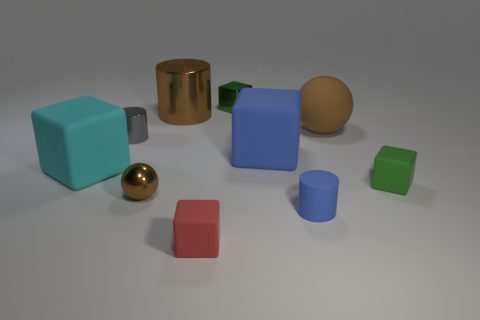Subtract all small red matte blocks. How many blocks are left? 4 Subtract all red blocks. How many blocks are left? 4 Subtract all brown cubes. Subtract all red cylinders. How many cubes are left? 5 Subtract all cylinders. How many objects are left? 7 Subtract 0 purple cylinders. How many objects are left? 10 Subtract all large matte things. Subtract all blue things. How many objects are left? 5 Add 5 metal cubes. How many metal cubes are left? 6 Add 8 big spheres. How many big spheres exist? 9 